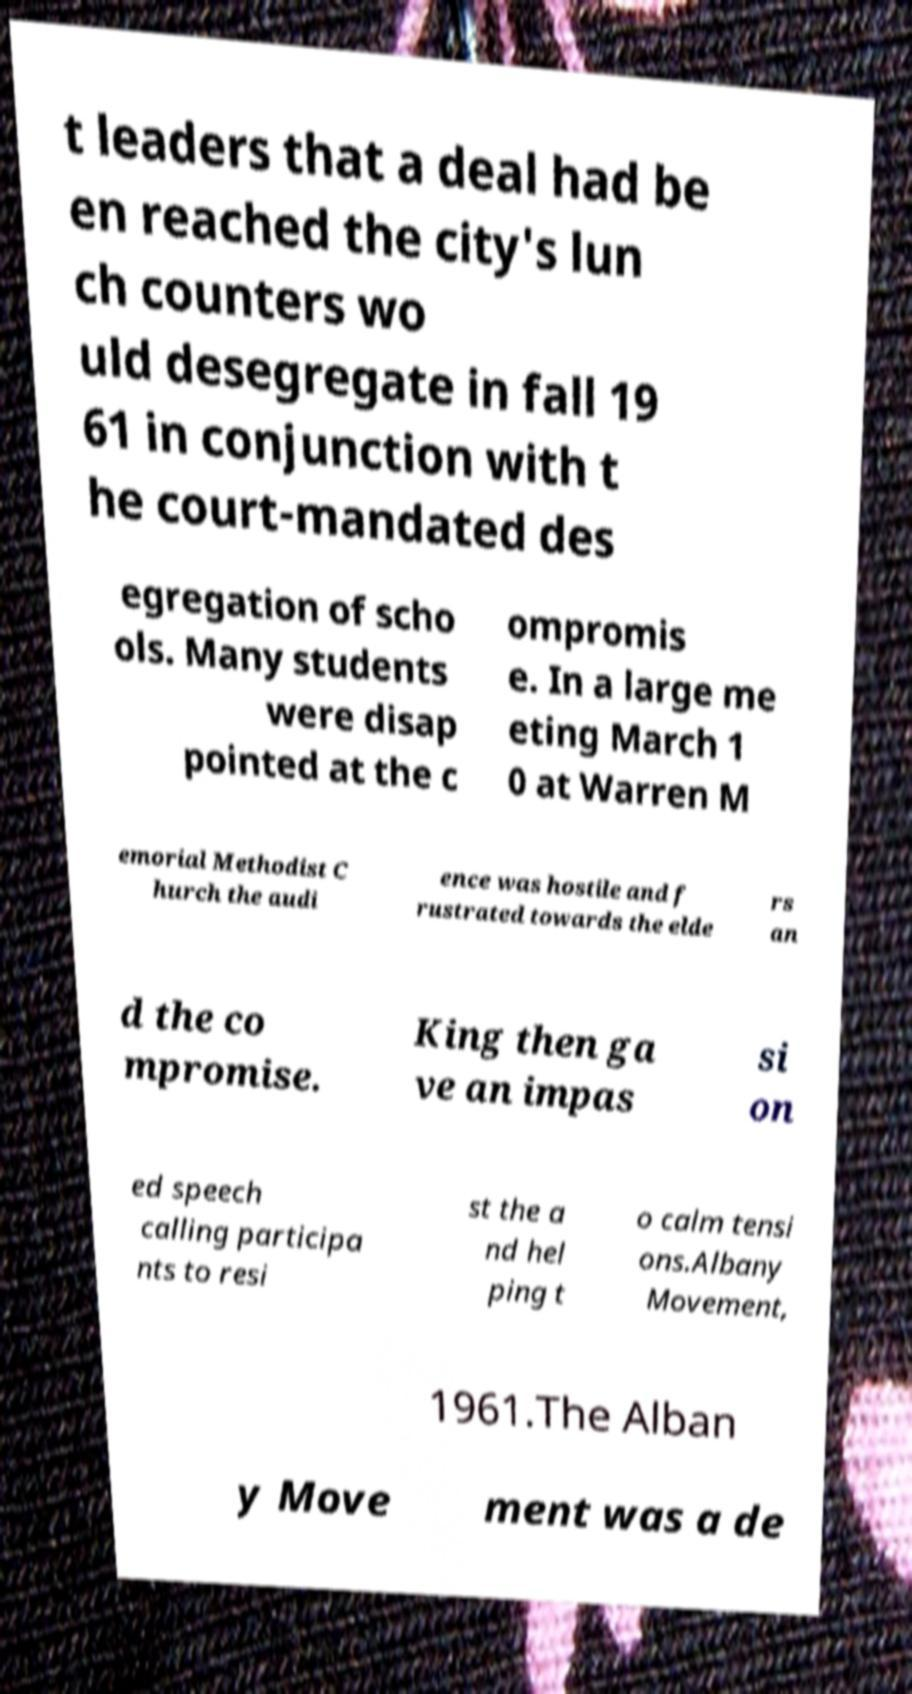Please identify and transcribe the text found in this image. t leaders that a deal had be en reached the city's lun ch counters wo uld desegregate in fall 19 61 in conjunction with t he court-mandated des egregation of scho ols. Many students were disap pointed at the c ompromis e. In a large me eting March 1 0 at Warren M emorial Methodist C hurch the audi ence was hostile and f rustrated towards the elde rs an d the co mpromise. King then ga ve an impas si on ed speech calling participa nts to resi st the a nd hel ping t o calm tensi ons.Albany Movement, 1961.The Alban y Move ment was a de 